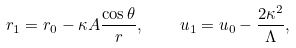Convert formula to latex. <formula><loc_0><loc_0><loc_500><loc_500>r _ { 1 } = r _ { 0 } - \kappa A \frac { \cos \theta } { r } , \quad u _ { 1 } = u _ { 0 } - \frac { 2 \kappa ^ { 2 } } { \Lambda } ,</formula> 